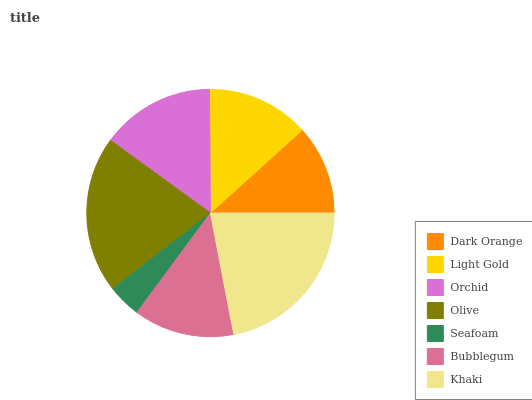Is Seafoam the minimum?
Answer yes or no. Yes. Is Khaki the maximum?
Answer yes or no. Yes. Is Light Gold the minimum?
Answer yes or no. No. Is Light Gold the maximum?
Answer yes or no. No. Is Light Gold greater than Dark Orange?
Answer yes or no. Yes. Is Dark Orange less than Light Gold?
Answer yes or no. Yes. Is Dark Orange greater than Light Gold?
Answer yes or no. No. Is Light Gold less than Dark Orange?
Answer yes or no. No. Is Light Gold the high median?
Answer yes or no. Yes. Is Light Gold the low median?
Answer yes or no. Yes. Is Orchid the high median?
Answer yes or no. No. Is Olive the low median?
Answer yes or no. No. 